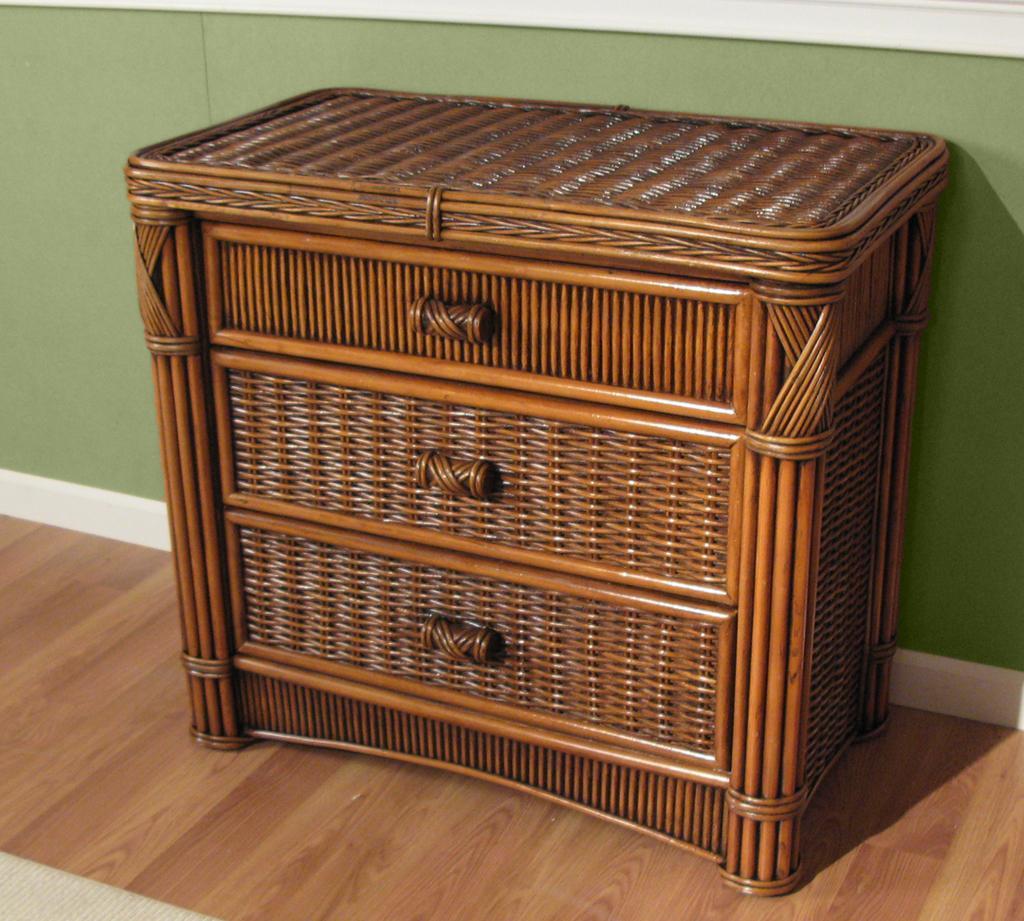In one or two sentences, can you explain what this image depicts? In this picture we can see a basket with racks to it and handles and this is placed on a floor and in the background we can see a green color wall. 